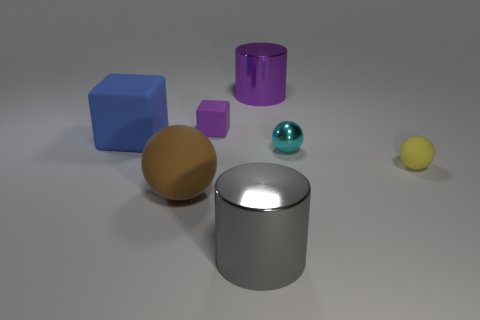Add 1 purple spheres. How many objects exist? 8 Subtract all cylinders. How many objects are left? 5 Subtract all small blue metal cylinders. Subtract all spheres. How many objects are left? 4 Add 3 large brown balls. How many large brown balls are left? 4 Add 2 big purple metallic cylinders. How many big purple metallic cylinders exist? 3 Subtract 0 blue spheres. How many objects are left? 7 